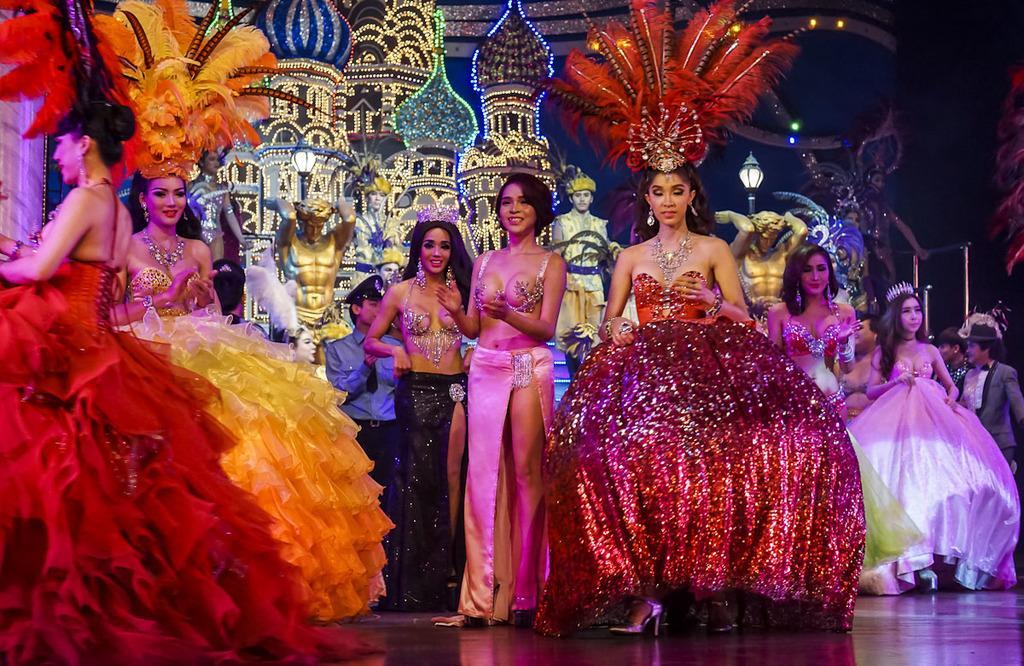How would you summarize this image in a sentence or two? In the image we can see there are people standing, wearing clothes and some of them are smiling. Here we can see floor, light pole and castle decoration. 